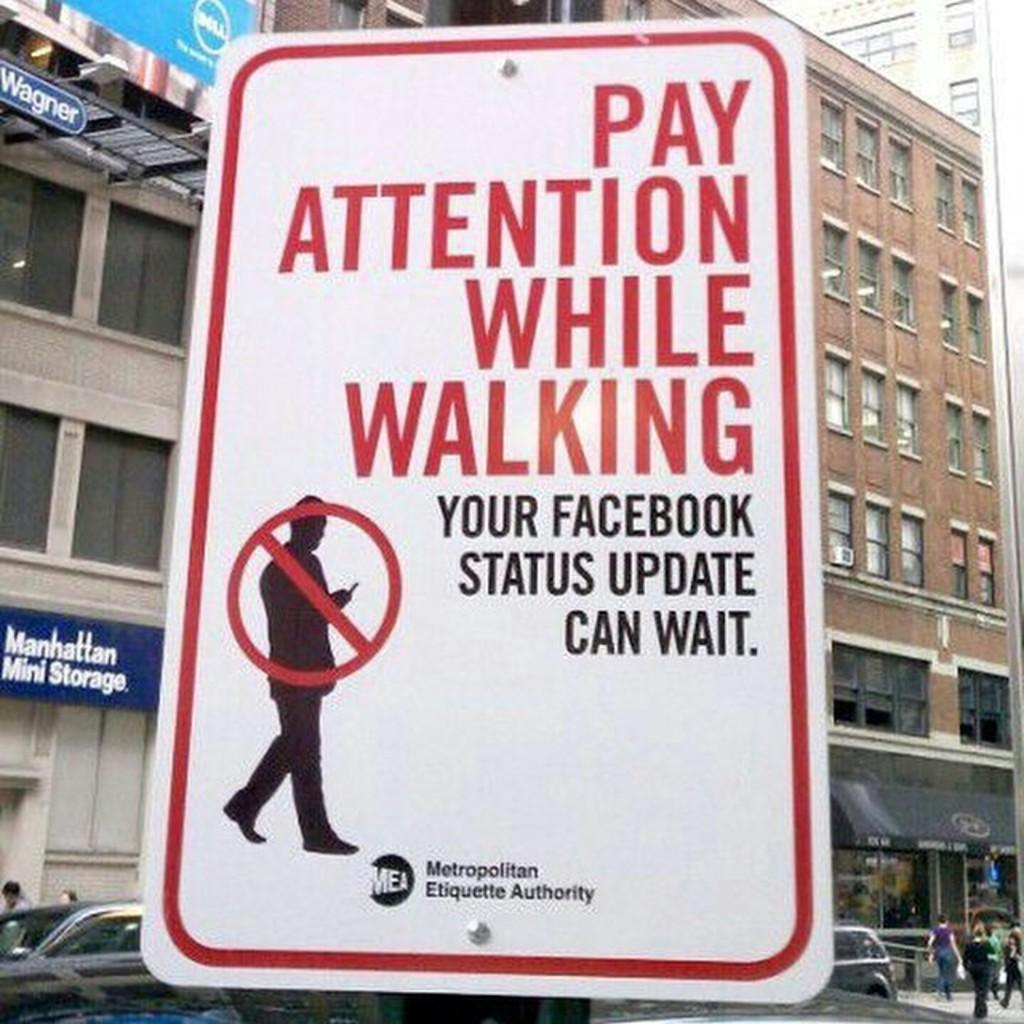<image>
Present a compact description of the photo's key features. A sign that reads pay attention while waking your facebook status update can wait. 